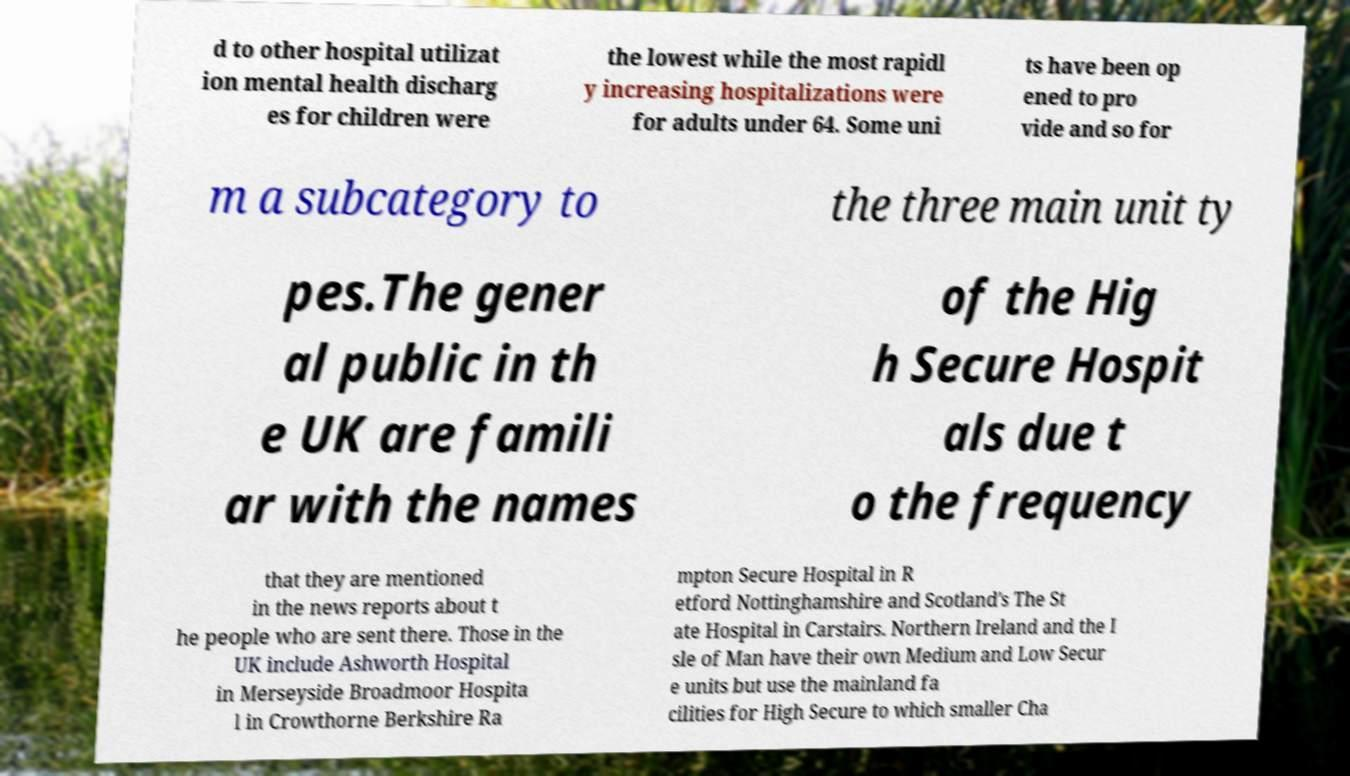For documentation purposes, I need the text within this image transcribed. Could you provide that? d to other hospital utilizat ion mental health discharg es for children were the lowest while the most rapidl y increasing hospitalizations were for adults under 64. Some uni ts have been op ened to pro vide and so for m a subcategory to the three main unit ty pes.The gener al public in th e UK are famili ar with the names of the Hig h Secure Hospit als due t o the frequency that they are mentioned in the news reports about t he people who are sent there. Those in the UK include Ashworth Hospital in Merseyside Broadmoor Hospita l in Crowthorne Berkshire Ra mpton Secure Hospital in R etford Nottinghamshire and Scotland's The St ate Hospital in Carstairs. Northern Ireland and the I sle of Man have their own Medium and Low Secur e units but use the mainland fa cilities for High Secure to which smaller Cha 